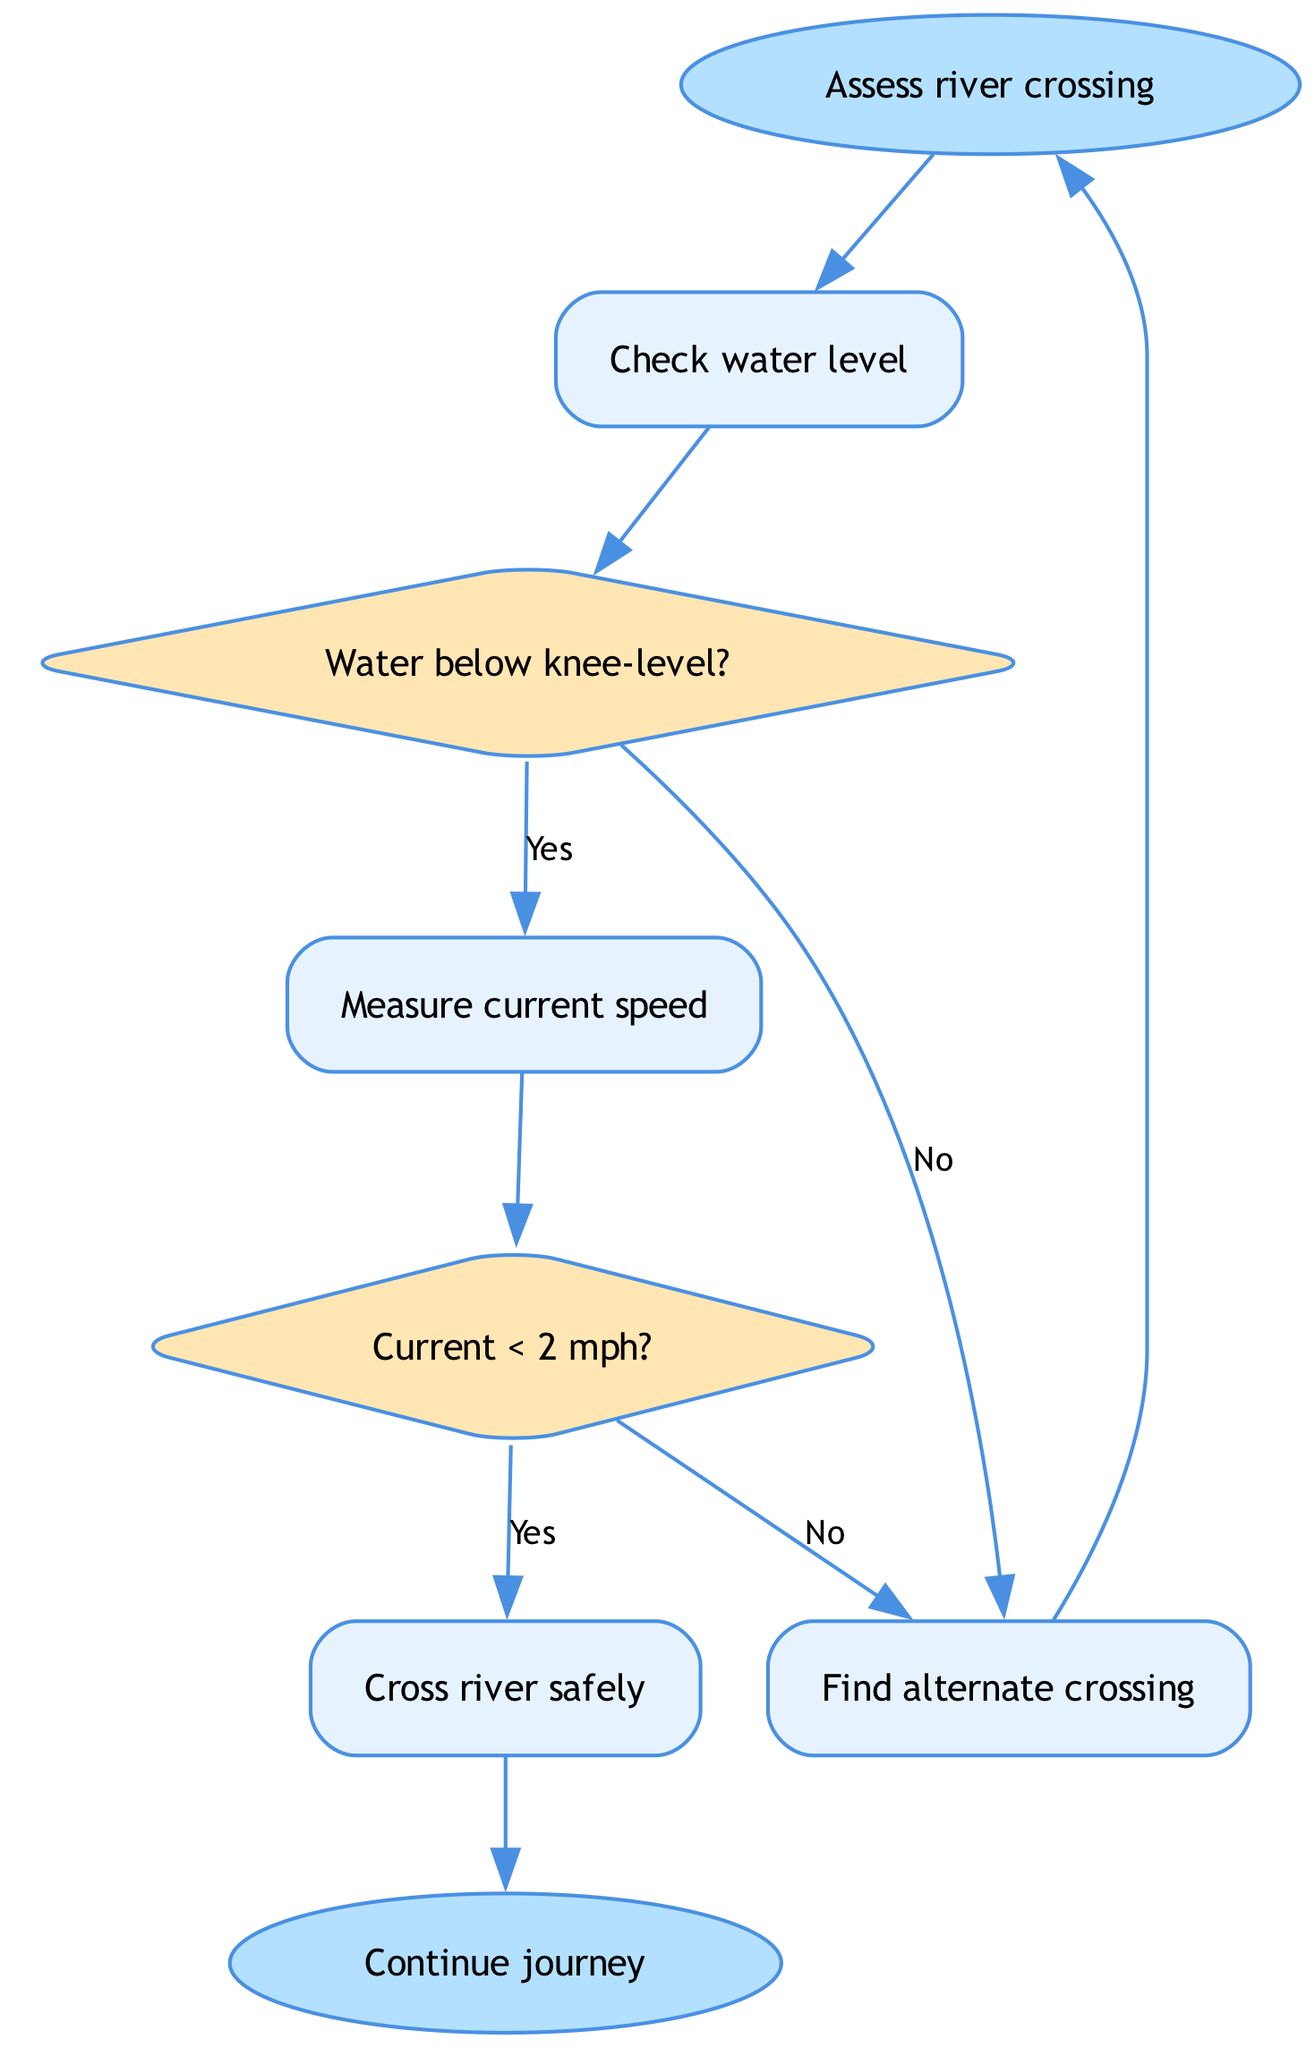What is the starting point of the flowchart? The flowchart begins at the node labeled "Assess river crossing," which is designated as the starting point of the decision-making process.
Answer: Assess river crossing How many nodes are present in the diagram? The diagram contains a total of 8 nodes, including both action nodes and decision points.
Answer: 8 What action occurs if the water level is above knee-level? If the water level is above knee-level (indicated by "No" from the node "Water below knee-level?"), the next action taken is to "Find alternate crossing."
Answer: Find alternate crossing What is the condition checked after determining the water level? After checking the water level, the next condition to be checked is the current speed, following the node labeled "Measure current speed."
Answer: Measure current speed What happens if the current is less than 2 mph? If the current is less than 2 mph (indicated by "Yes" from the node "Current < 2 mph?"), the next action is to "Cross river safely."
Answer: Cross river safely What leads to the end of the flowchart? The flowchart ends after the action "Cross river safely" is executed, followed by the end node labeled "Continue journey."
Answer: Continue journey If the current speed is greater than or equal to 2 mph, what is the outcome? If the current speed is greater than or equal to 2 mph (indicated by "No" from the node "Current < 2 mph?"), the next step is to "Find alternate crossing."
Answer: Find alternate crossing What is the decision-making process regarding the water level in the flowchart? The flowchart first checks if the water is below knee-level; if yes, it proceeds to check the current speed, otherwise, it leads to finding an alternate crossing.
Answer: Check current speed What type of nodes are used to represent decisions in the flowchart? The decisions in the flowchart are represented by diamond-shaped nodes, which typically indicate branching points based on certain conditions.
Answer: Diamond-shaped nodes 